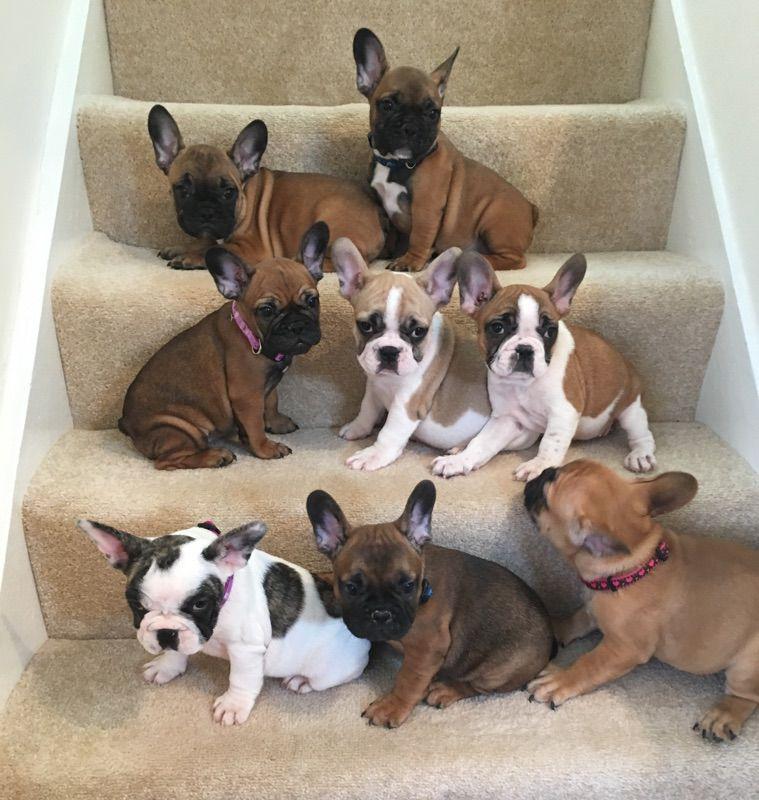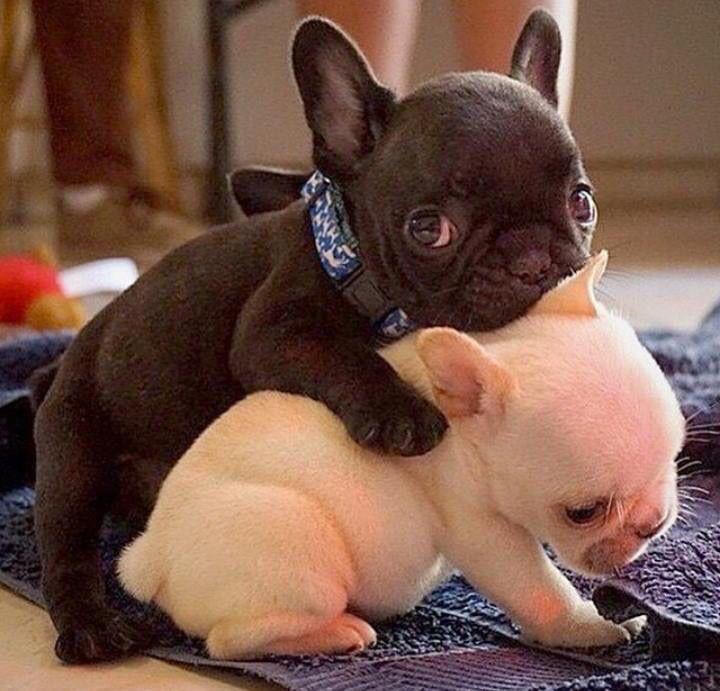The first image is the image on the left, the second image is the image on the right. Evaluate the accuracy of this statement regarding the images: "There is only one puppy in the picture on the left.". Is it true? Answer yes or no. No. The first image is the image on the left, the second image is the image on the right. For the images shown, is this caption "An image shows a row of at least three puppies of the same overall color." true? Answer yes or no. No. 